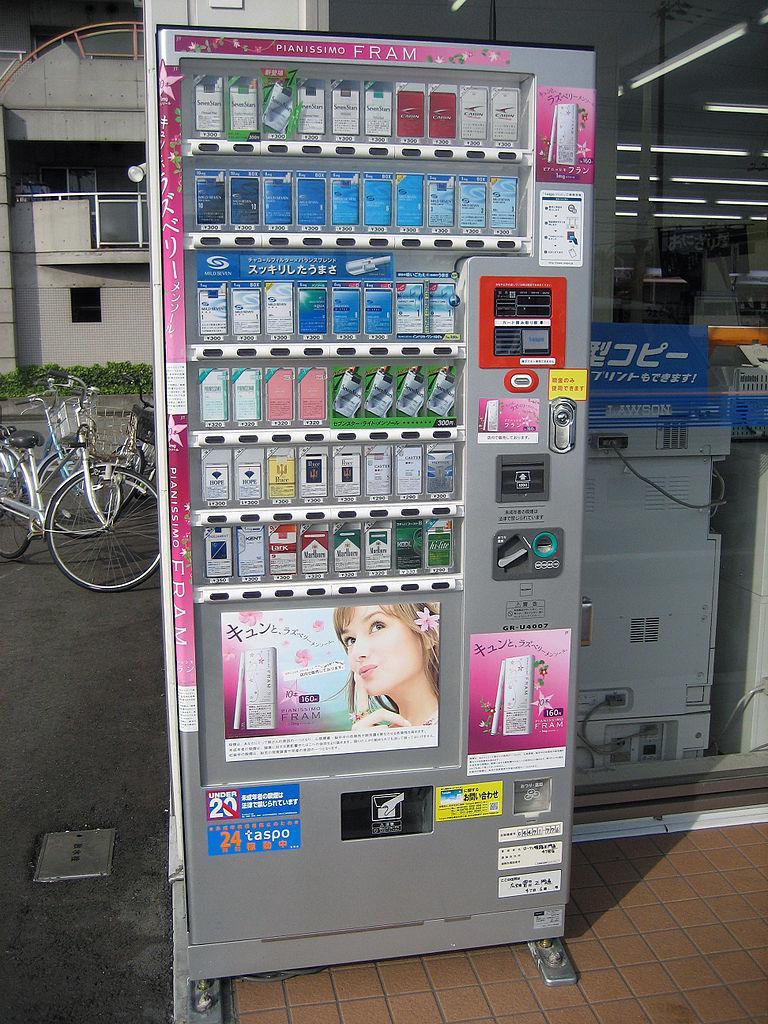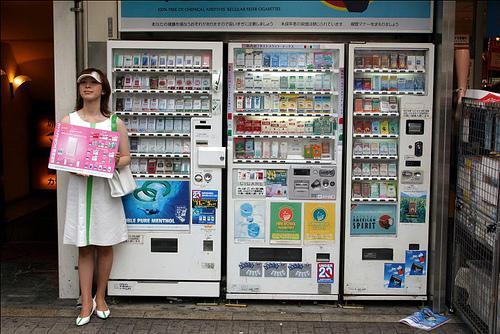The first image is the image on the left, the second image is the image on the right. For the images displayed, is the sentence "A display has two identical green labeled drinks in the upper left corner." factually correct? Answer yes or no. No. The first image is the image on the left, the second image is the image on the right. Analyze the images presented: Is the assertion "Only three shelves of items are visible in the vending machine in the image on the left" valid? Answer yes or no. No. 